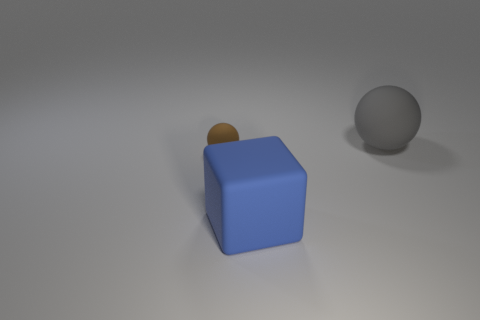Are there any other things that have the same size as the brown sphere?
Give a very brief answer. No. The tiny matte object that is left of the large matte object that is behind the large thing that is in front of the gray thing is what shape?
Your answer should be very brief. Sphere. There is a object that is both behind the matte block and in front of the big ball; what material is it?
Ensure brevity in your answer.  Rubber. What shape is the thing right of the thing that is in front of the brown sphere?
Your response must be concise. Sphere. Is there anything else that is the same color as the big sphere?
Provide a short and direct response. No. Do the brown ball and the rubber sphere right of the small matte object have the same size?
Give a very brief answer. No. What number of tiny things are either blue rubber cubes or metallic things?
Provide a short and direct response. 0. Is the number of brown balls greater than the number of objects?
Your response must be concise. No. What number of large rubber blocks are on the left side of the large matte object that is in front of the sphere left of the blue rubber block?
Your answer should be very brief. 0. The large blue thing has what shape?
Your answer should be compact. Cube. 